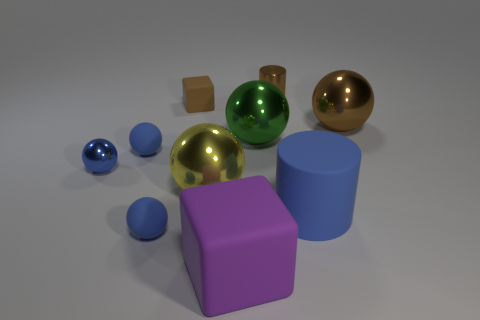Subtract all large yellow balls. How many balls are left? 5 Subtract all cylinders. How many objects are left? 8 Subtract 1 cubes. How many cubes are left? 1 Subtract all green blocks. Subtract all blue balls. How many blocks are left? 2 Subtract all gray cubes. How many gray cylinders are left? 0 Subtract all cylinders. Subtract all large green rubber spheres. How many objects are left? 8 Add 6 tiny metal balls. How many tiny metal balls are left? 7 Add 1 tiny blue metallic balls. How many tiny blue metallic balls exist? 2 Subtract all brown cylinders. How many cylinders are left? 1 Subtract 0 green blocks. How many objects are left? 10 